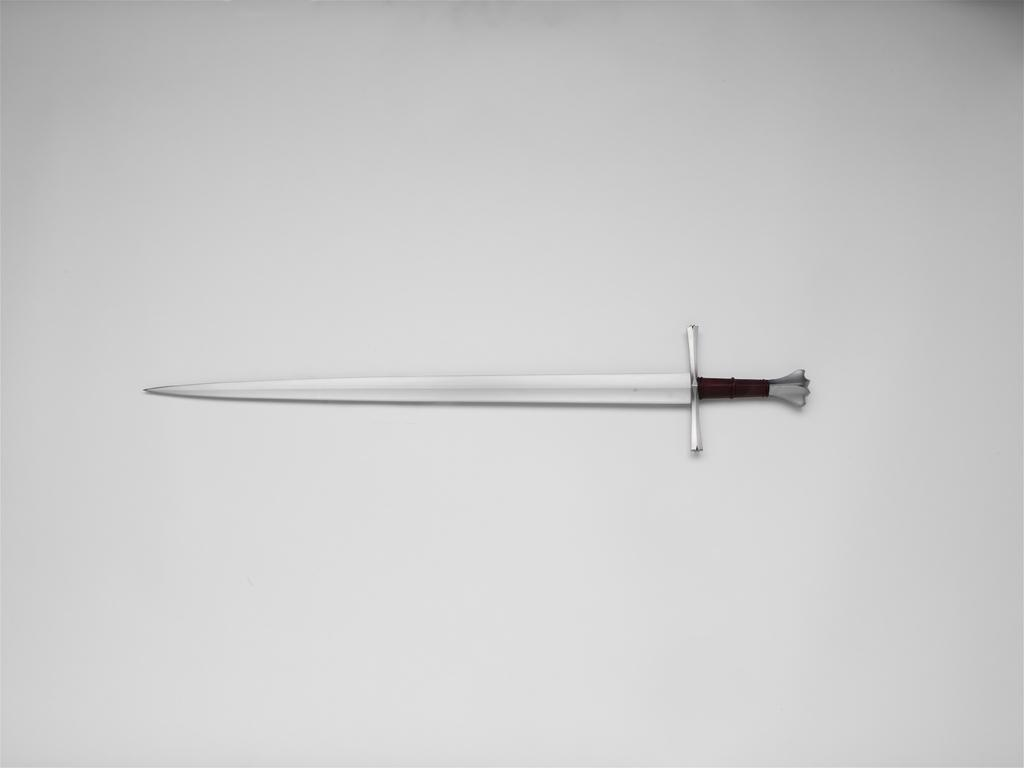What is the main object in the image? There is a sword in the image. What is the sword placed on? The sword is on a white object. Can you tell me the route the fairies take to reach the sword in the image? There are no fairies present in the image, so it is not possible to determine their route to the sword. 